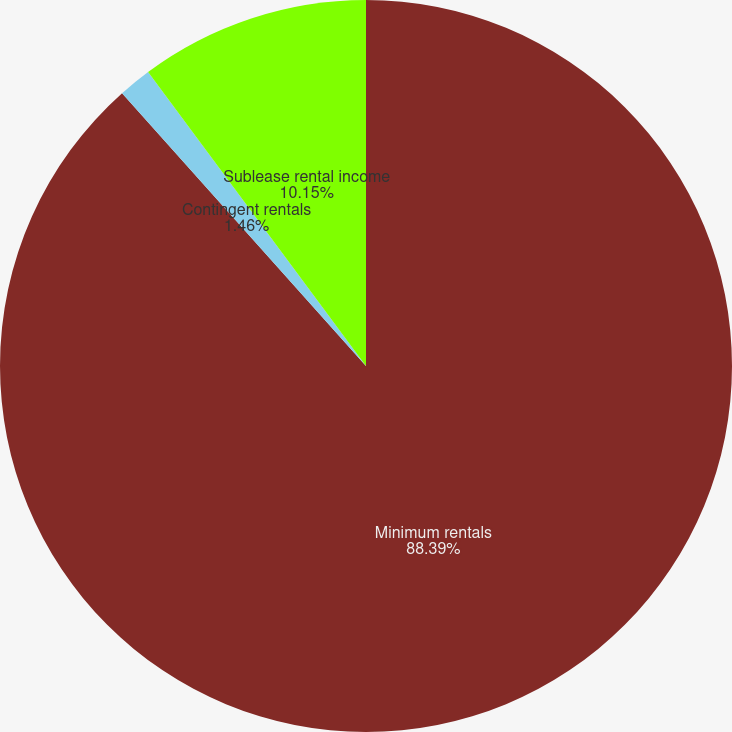<chart> <loc_0><loc_0><loc_500><loc_500><pie_chart><fcel>Minimum rentals<fcel>Contingent rentals<fcel>Sublease rental income<nl><fcel>88.39%<fcel>1.46%<fcel>10.15%<nl></chart> 